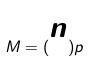<formula> <loc_0><loc_0><loc_500><loc_500>M = ( \begin{matrix} n \\ 2 \end{matrix} ) p</formula> 